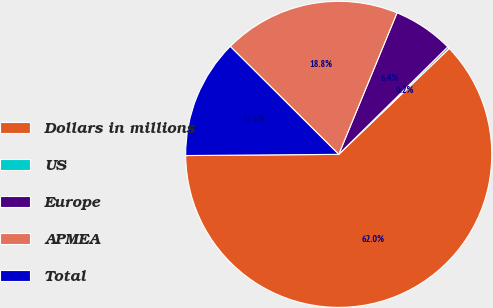Convert chart. <chart><loc_0><loc_0><loc_500><loc_500><pie_chart><fcel>Dollars in millions<fcel>US<fcel>Europe<fcel>APMEA<fcel>Total<nl><fcel>62.04%<fcel>0.22%<fcel>6.4%<fcel>18.76%<fcel>12.58%<nl></chart> 